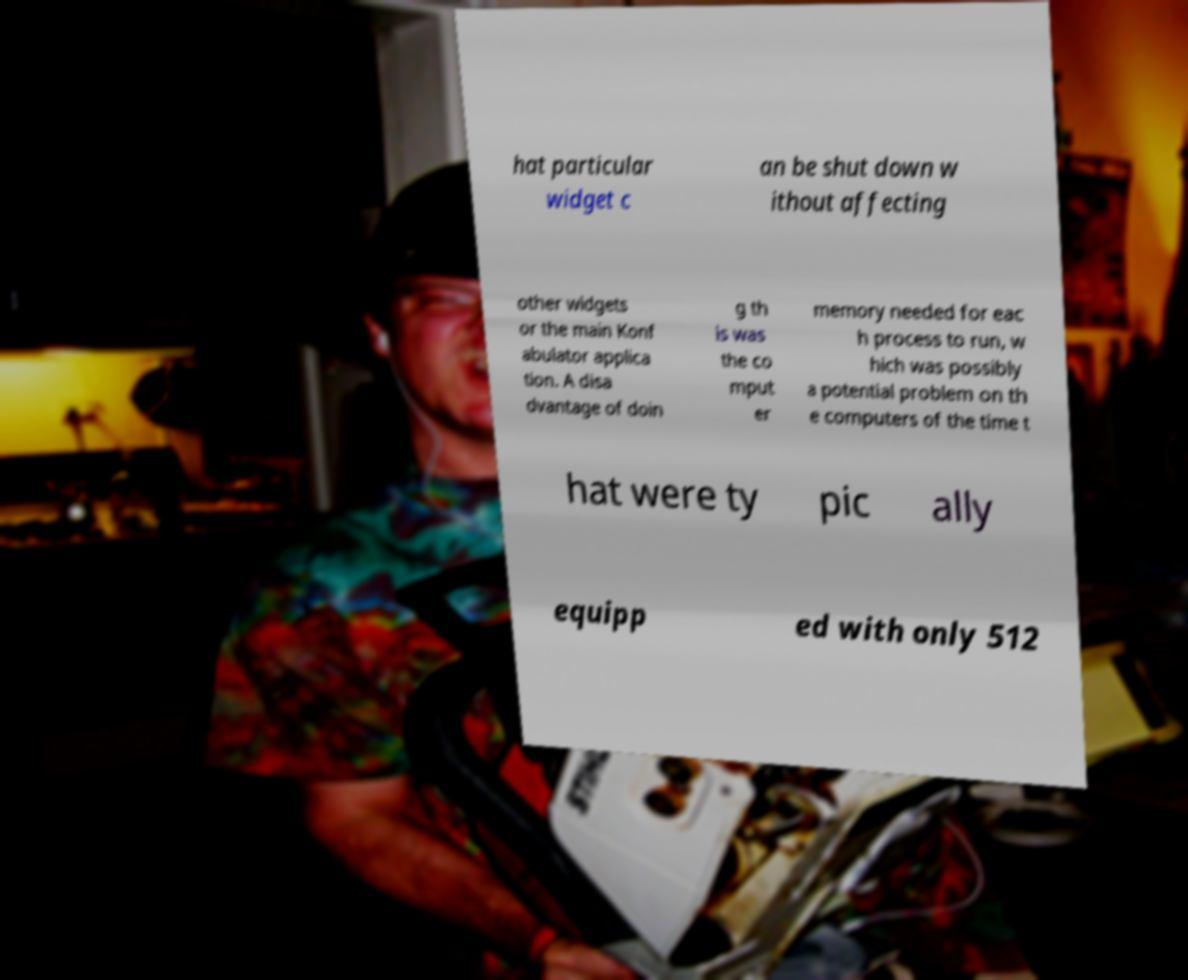Could you assist in decoding the text presented in this image and type it out clearly? hat particular widget c an be shut down w ithout affecting other widgets or the main Konf abulator applica tion. A disa dvantage of doin g th is was the co mput er memory needed for eac h process to run, w hich was possibly a potential problem on th e computers of the time t hat were ty pic ally equipp ed with only 512 